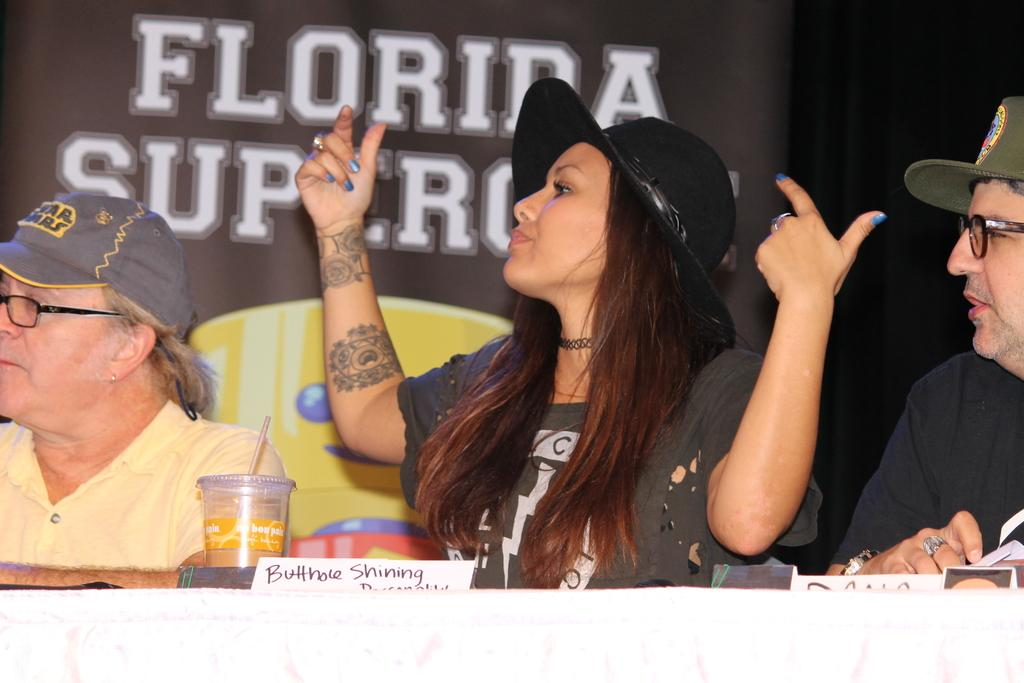How many people are sitting in the image? There are three people sitting in the image. What is in front of the people? There is a table in front of the people. What is on the table? A name plate, juice, and a banner are present on the table. What is the banner like? The banner has some text and an image. How does the feeling of the grandfather affect the people in the image? There is no mention of a grandfather in the image, so it is not possible to determine how his feelings might affect the people in the image. 